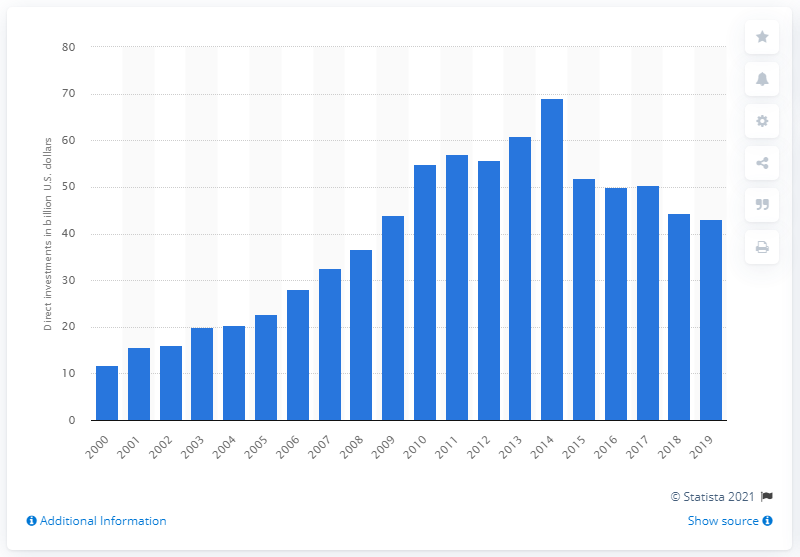List a handful of essential elements in this visual. Foreign direct investment in Africa reached its peak in 2014. The amount of FDI from the United States in Africa in 2019 was 43.19. 